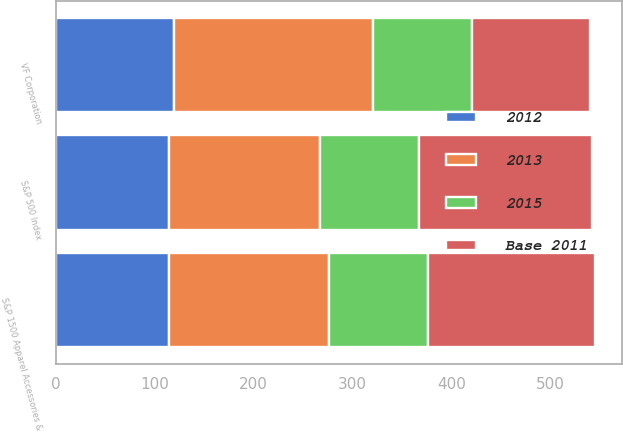Convert chart. <chart><loc_0><loc_0><loc_500><loc_500><stacked_bar_chart><ecel><fcel>VF Corporation<fcel>S&P 500 Index<fcel>S&P 1500 Apparel Accessories &<nl><fcel>2015<fcel>100<fcel>100<fcel>100<nl><fcel>2012<fcel>119.19<fcel>114.07<fcel>114.77<nl><fcel>2013<fcel>201.79<fcel>152.98<fcel>161.05<nl><fcel>Base 2011<fcel>119.19<fcel>174.56<fcel>169.73<nl></chart> 